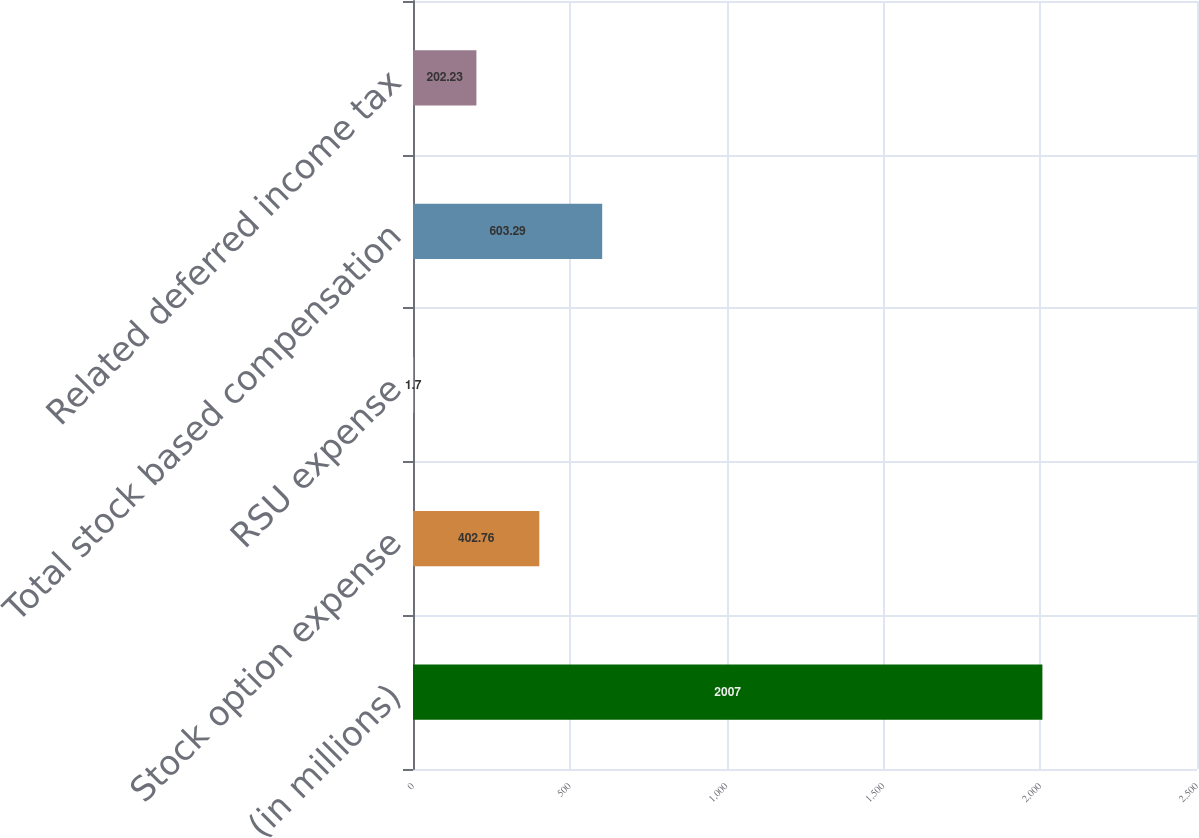<chart> <loc_0><loc_0><loc_500><loc_500><bar_chart><fcel>(in millions)<fcel>Stock option expense<fcel>RSU expense<fcel>Total stock based compensation<fcel>Related deferred income tax<nl><fcel>2007<fcel>402.76<fcel>1.7<fcel>603.29<fcel>202.23<nl></chart> 